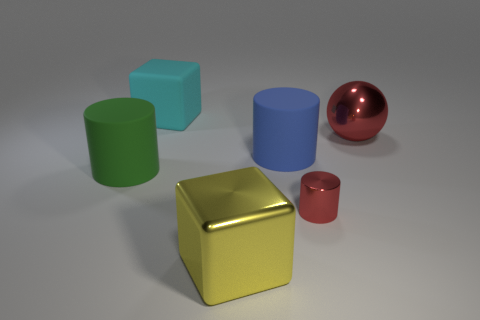Are there any metallic objects that have the same color as the large ball?
Keep it short and to the point. Yes. There is a cylinder that is made of the same material as the large green object; what size is it?
Offer a terse response. Large. Are there more big red metallic objects on the right side of the cyan cube than big blue things that are right of the red ball?
Ensure brevity in your answer.  Yes. What number of other things are the same material as the large yellow thing?
Your answer should be compact. 2. Do the red thing in front of the blue matte thing and the big red sphere have the same material?
Your answer should be very brief. Yes. What is the shape of the cyan object?
Your response must be concise. Cube. Are there more large blue rubber cylinders on the right side of the large green rubber thing than large green matte cubes?
Your answer should be compact. Yes. Is there anything else that has the same shape as the big red object?
Make the answer very short. No. There is another matte thing that is the same shape as the large yellow thing; what color is it?
Your answer should be very brief. Cyan. There is a large red metal object behind the large yellow cube; what is its shape?
Your response must be concise. Sphere. 